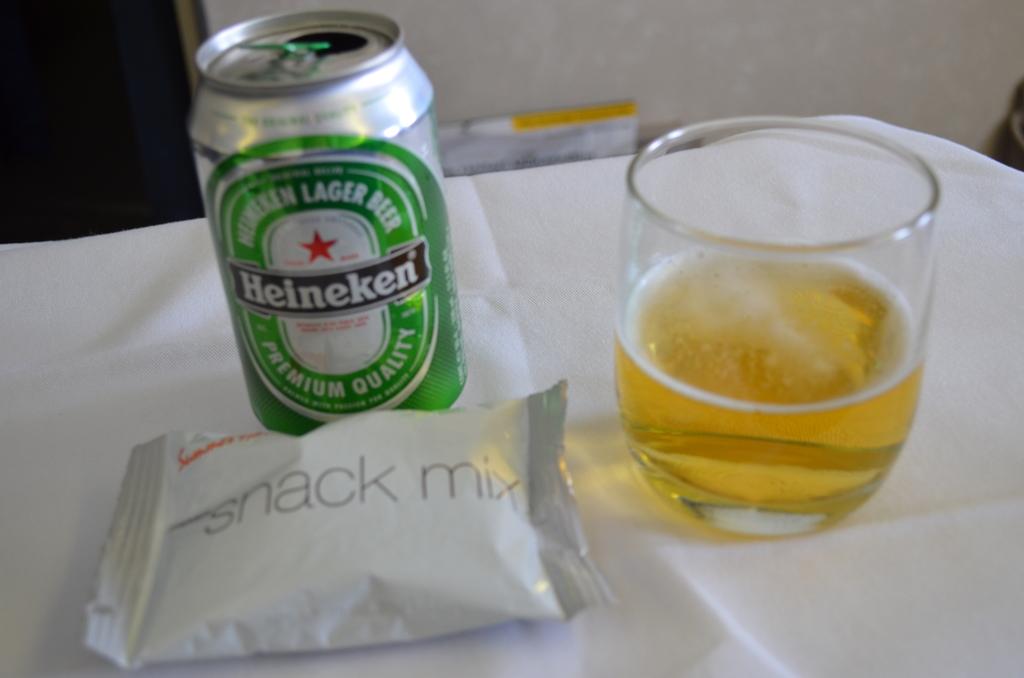Why type mix is the bag?
Keep it short and to the point. Snack. What brand of beer is shown?
Offer a terse response. Heineken. 